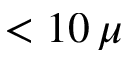Convert formula to latex. <formula><loc_0><loc_0><loc_500><loc_500>< 1 0 \, \mu</formula> 